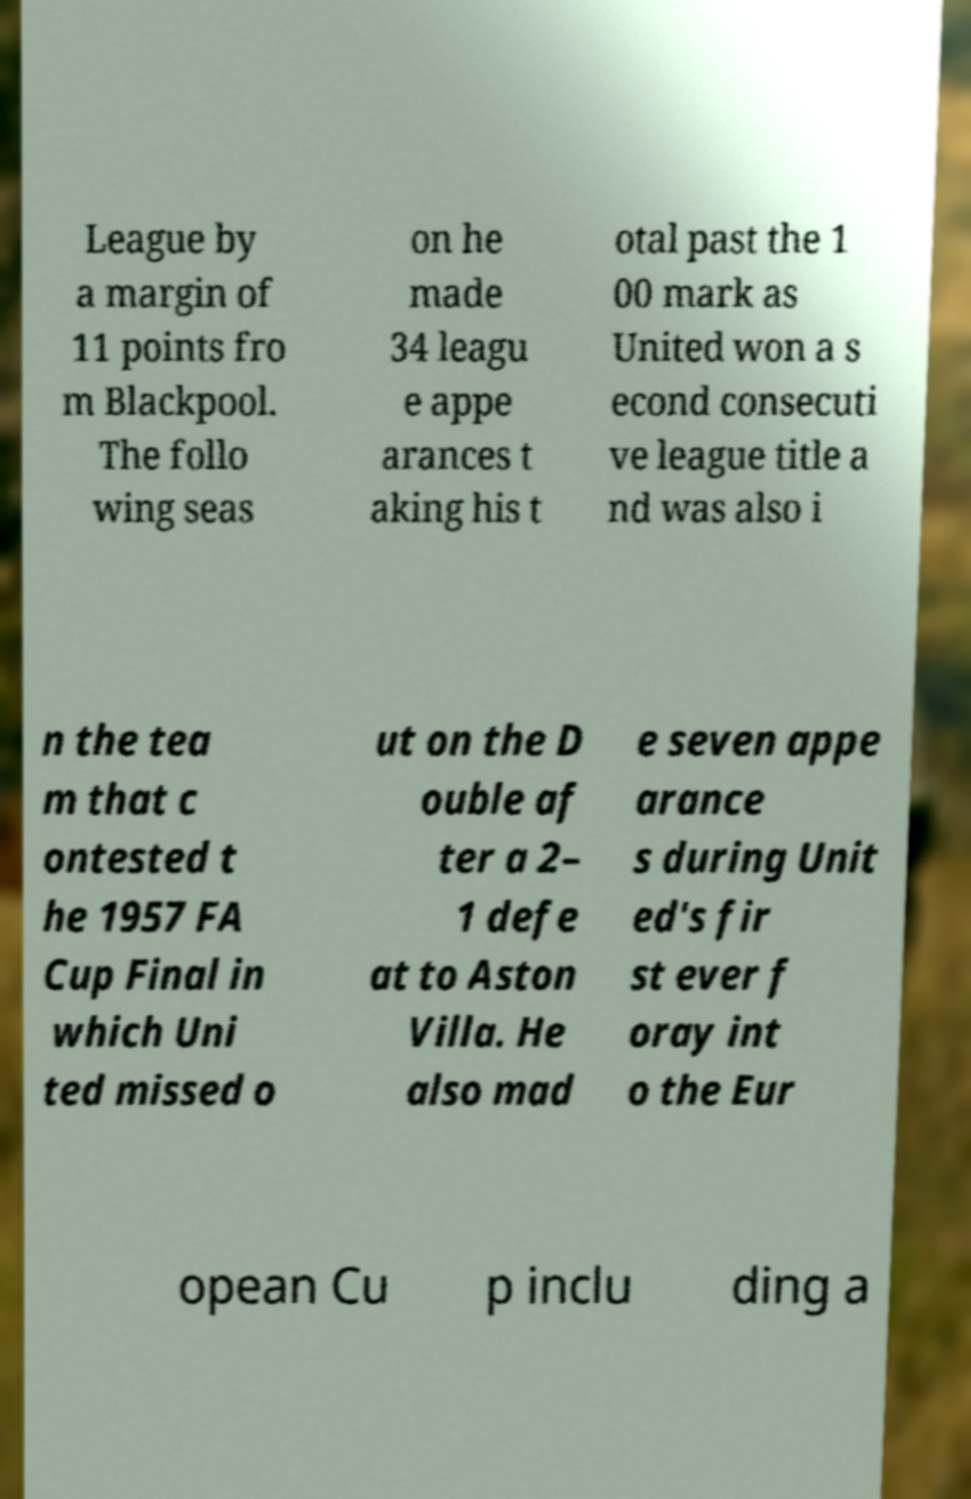Please read and relay the text visible in this image. What does it say? League by a margin of 11 points fro m Blackpool. The follo wing seas on he made 34 leagu e appe arances t aking his t otal past the 1 00 mark as United won a s econd consecuti ve league title a nd was also i n the tea m that c ontested t he 1957 FA Cup Final in which Uni ted missed o ut on the D ouble af ter a 2– 1 defe at to Aston Villa. He also mad e seven appe arance s during Unit ed's fir st ever f oray int o the Eur opean Cu p inclu ding a 